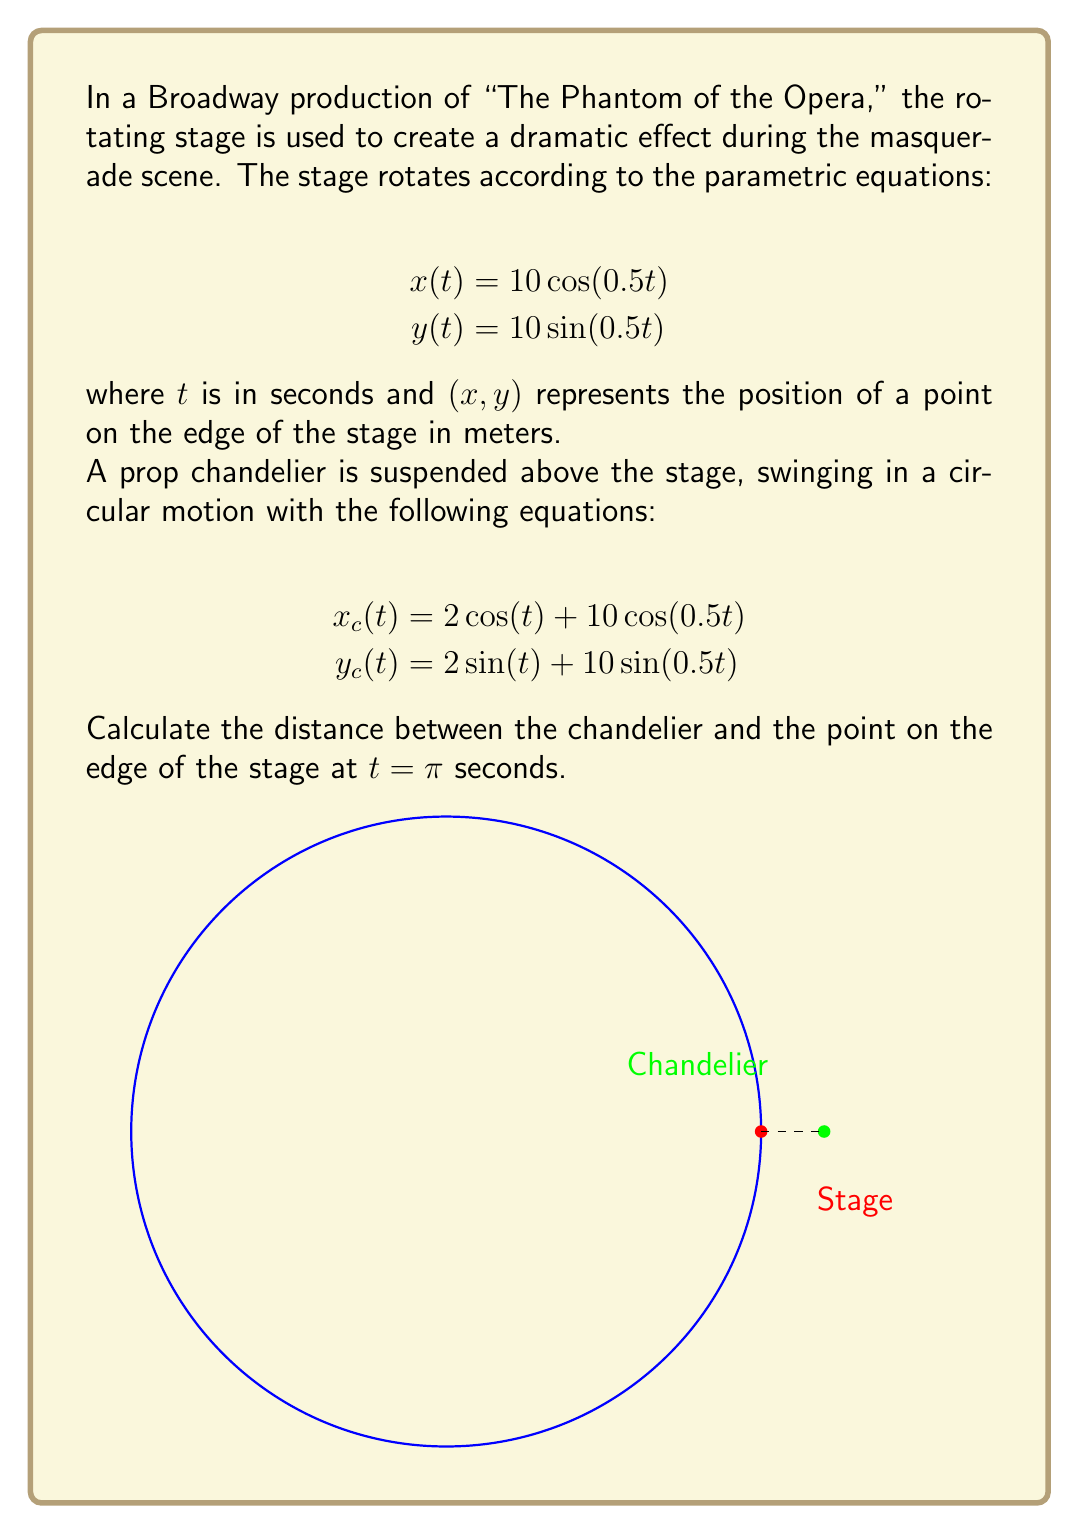Teach me how to tackle this problem. Let's approach this step-by-step:

1) First, we need to find the coordinates of the point on the edge of the stage at $t = \pi$:
   $$x(π) = 10\cos(0.5π) = 10 \cdot 0 = 0$$
   $$y(π) = 10\sin(0.5π) = 10 \cdot 1 = 10$$
   So, the point on the stage is at (0, 10).

2) Next, we find the coordinates of the chandelier at $t = π$:
   $$x_c(π) = 2\cos(π) + 10\cos(0.5π) = -2 + 0 = -2$$
   $$y_c(π) = 2\sin(π) + 10\sin(0.5π) = 0 + 10 = 10$$
   The chandelier is at (-2, 10).

3) Now, we can calculate the distance between these two points using the distance formula:
   $$d = \sqrt{(x_2-x_1)^2 + (y_2-y_1)^2}$$
   where $(x_1,y_1)$ is the stage point and $(x_2,y_2)$ is the chandelier.

4) Plugging in our values:
   $$d = \sqrt{(-2-0)^2 + (10-10)^2}$$
   $$d = \sqrt{(-2)^2 + 0^2}$$
   $$d = \sqrt{4}$$
   $$d = 2$$

Therefore, the distance between the chandelier and the point on the edge of the stage at $t = π$ seconds is 2 meters.
Answer: 2 meters 